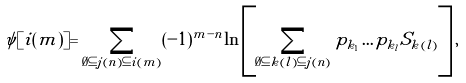<formula> <loc_0><loc_0><loc_500><loc_500>\psi [ i ( m ) ] = \sum _ { \emptyset \subseteq j ( n ) \subseteq i ( m ) } ( - 1 ) ^ { m - n } \ln \left [ \sum _ { \emptyset \subseteq k ( l ) \subseteq j ( n ) } p _ { k _ { 1 } } \dots p _ { k _ { l } } S _ { k ( l ) } \right ] ,</formula> 